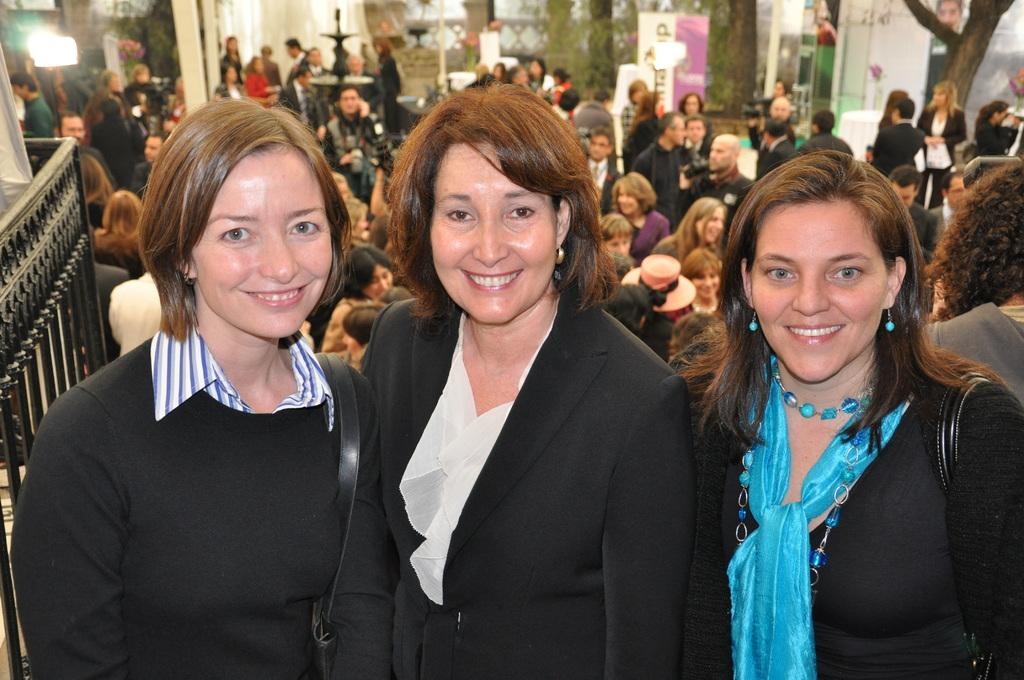How many women are in the image? There are three women in the image. Can you describe the background of the image? There are people visible in the background of the image. What is a feature that separates the foreground from the background? There is a fence in the image. What type of vegetation can be seen in the image? There are trees in the image. What type of architectural feature is present in the image? There are glass doors in the image. What type of bag is the woman on the left holding in the image? There is no bag visible in the image; the women are not holding any bags. 